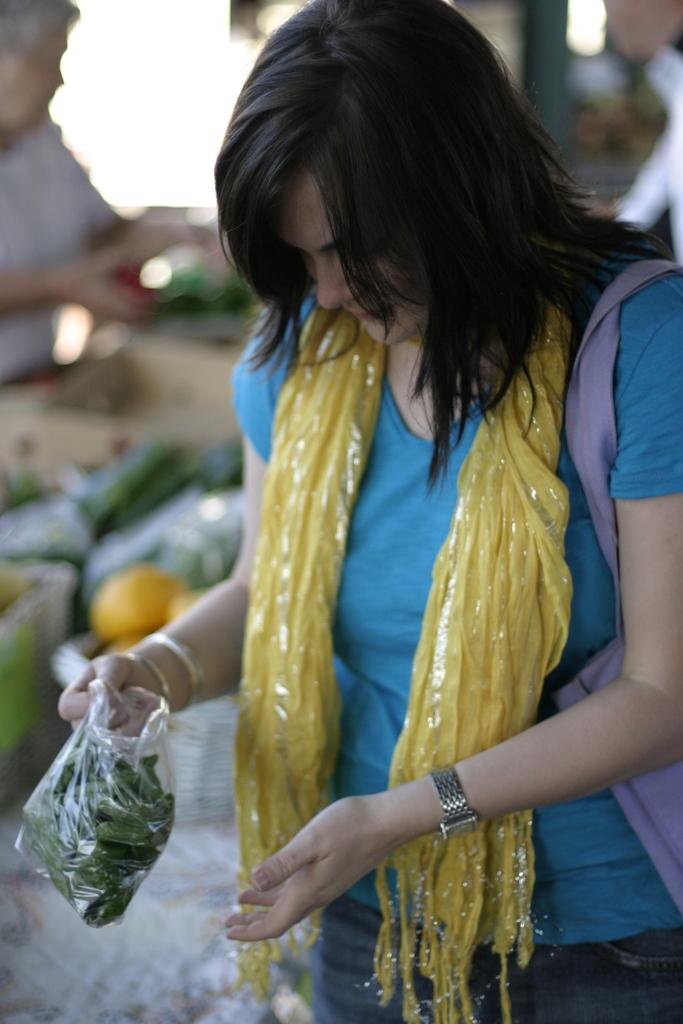What is the main subject of the image? There is a woman standing in the image. Can you describe the woman's attire? The woman is wearing clothes, a wrist watch, and a bracelet. What accessories can be seen in the image? There is a handbag and a scarf in the image. What is covering the woman's belongings? There is a plastic cover in the image. How would you describe the background of the image? The background of the image is blurred. What type of credit card is the woman holding in the image? There is no credit card visible in the image. Is there a cushion on the ground in the image? There is no cushion present in the image. 